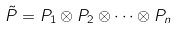<formula> <loc_0><loc_0><loc_500><loc_500>\tilde { P } = P _ { 1 } \otimes P _ { 2 } \otimes \cdots \otimes P _ { n }</formula> 